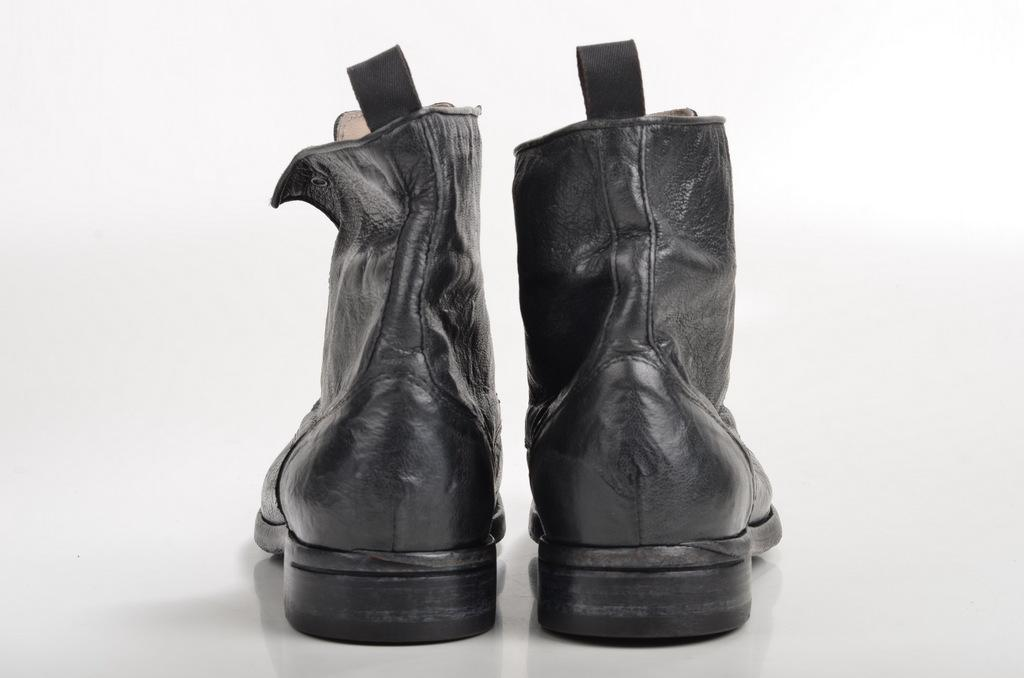What type of footwear is visible in the image? There is a pair of black color boots in the image. What color is the background of the image? The background of the image is white. What is the range of the boots in the image? The boots do not have a range, as they are a static object in the image. Is the person wearing the boots driving in the image? There is no person or driving activity depicted in the image; it only shows a pair of boots and a white background. 